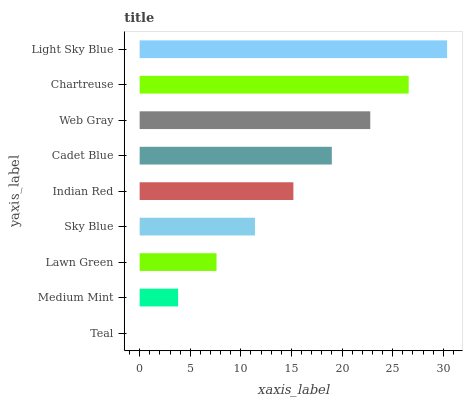Is Teal the minimum?
Answer yes or no. Yes. Is Light Sky Blue the maximum?
Answer yes or no. Yes. Is Medium Mint the minimum?
Answer yes or no. No. Is Medium Mint the maximum?
Answer yes or no. No. Is Medium Mint greater than Teal?
Answer yes or no. Yes. Is Teal less than Medium Mint?
Answer yes or no. Yes. Is Teal greater than Medium Mint?
Answer yes or no. No. Is Medium Mint less than Teal?
Answer yes or no. No. Is Indian Red the high median?
Answer yes or no. Yes. Is Indian Red the low median?
Answer yes or no. Yes. Is Chartreuse the high median?
Answer yes or no. No. Is Web Gray the low median?
Answer yes or no. No. 